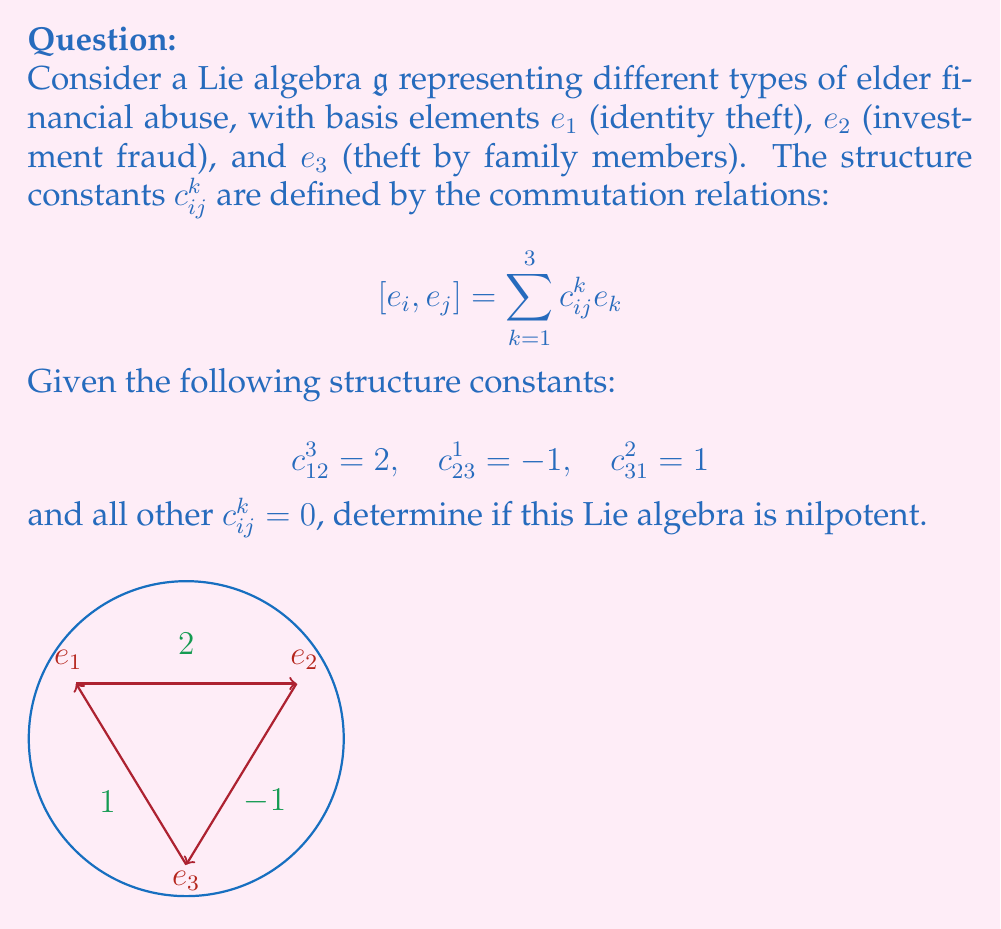Teach me how to tackle this problem. To determine if the Lie algebra is nilpotent, we need to check if its lower central series terminates at zero in finitely many steps. Let's follow these steps:

1) First, let's calculate $\mathfrak{g}^1 = [\mathfrak{g}, \mathfrak{g}]$:
   
   $[e_1, e_2] = 2e_3$
   $[e_2, e_3] = -e_1$
   $[e_3, e_1] = e_2$

   Therefore, $\mathfrak{g}^1 = \mathfrak{g}$, as it spans all basis elements.

2) Next, let's calculate $\mathfrak{g}^2 = [\mathfrak{g}, \mathfrak{g}^1]$:
   
   $[e_1, [e_1, e_2]] = [e_1, 2e_3] = 2e_2$
   $[e_1, [e_2, e_3]] = [e_1, -e_1] = 0$
   $[e_1, [e_3, e_1]] = [e_1, e_2] = 2e_3$

   Similar calculations for $e_2$ and $e_3$ show that $\mathfrak{g}^2 = \mathfrak{g}$ as well.

3) Since $\mathfrak{g}^2 = \mathfrak{g}^1 = \mathfrak{g}$, the lower central series does not terminate at zero.

Therefore, this Lie algebra is not nilpotent.

In the context of elder financial abuse, this result suggests that the interrelations between different types of abuse (identity theft, investment fraud, and theft by family members) form a persistent structure that doesn't "die out" or simplify over repeated analyses.
Answer: Not nilpotent 